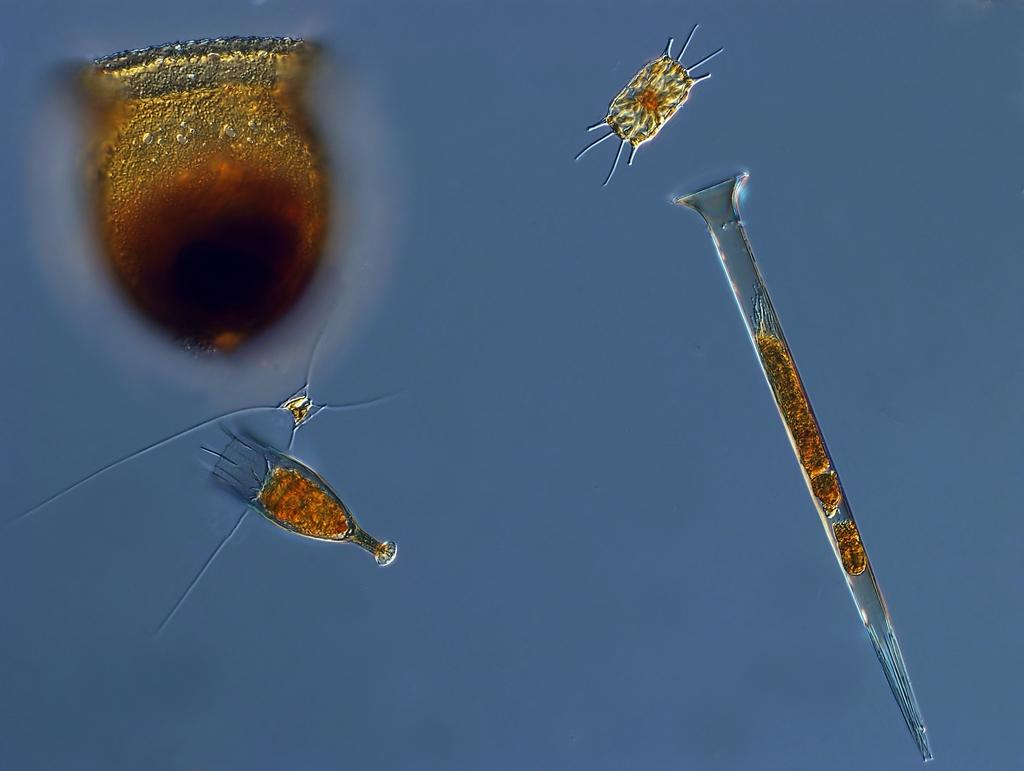What is the main subject of the image? The main subject of the image is related to microorganisms. What type of poison is being used by the bat in the image? There is no bat or poison present in the image; it is related to microorganisms. 